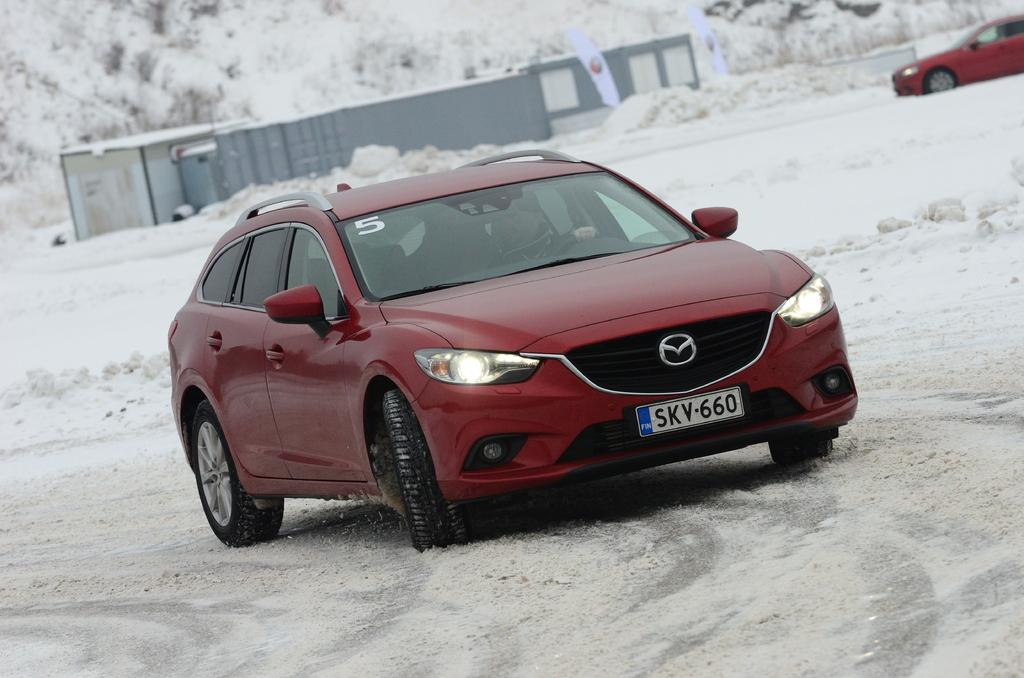What is happening in the image? There are cars on a road in the image. What is the condition of the road? The road is covered with snow. What can be seen in the background of the image? There are two sheds and trees in the background of the image. What type of cake is being served at the camp in the image? There is no cake or camp present in the image; it features cars on a snow-covered road with sheds and trees in the background. 